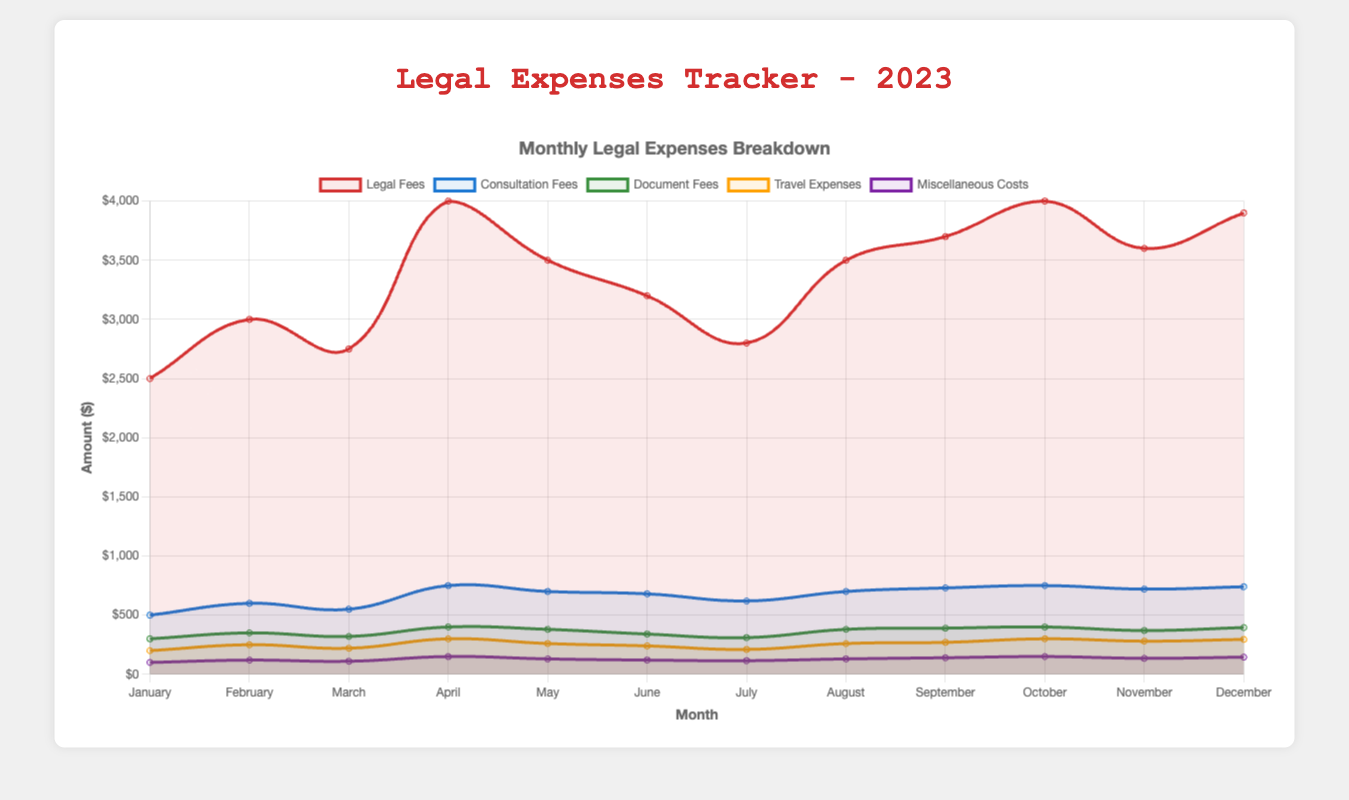What's the highest legal fee recorded in 2023? The highest legal fee can be found by looking at the peak value in the "Legal Fees" line. According to the chart, both April and October have the highest value of $4000.
Answer: $4000 Which month had the lowest consultation fees? To find the month with the lowest consultation fees, trace the "Consultation Fees" line to the lowest point on the chart. January has the lowest consultation fees at $500.
Answer: January What is the total amount spent on miscellaneous costs in the first quarter of 2023? The first quarter includes January, February, and March. Summing up the miscellaneous costs for these months: $100 (January) + $120 (February) + $110 (March) = $330.
Answer: $330 How do the travel expenses in June compare to those in November? June's travel expenses are $240, while November's travel expenses are $280. Comparing these values, November's travel expenses are higher.
Answer: November has higher travel expenses What is the overall trend in legal fees from January to December 2023? To identify the trend, observe the "Legal Fees" line from January to December. Initially, there's an upward trend until April, followed by fluctuations, and a peak in October before ending at a slightly lower value in December.
Answer: Fluctuating with peaks in April and October Which month had the highest total costs when combining all categories? To find the month with the highest total costs, sum all the categories (Legal Fees, Consultation Fees, Document Fees, Travel Expenses, Miscellaneous Costs) for each month and compare. April has $4000 (Legal Fees) + $750 (Consultation Fees) + $400 (Document Fees) + $300 (Travel Expenses) + $150 (Miscellaneous Costs) = $5600. This is the highest combined cost.
Answer: April What is the average document fee over the entire year? Sum of all monthly document fees divided by the number of months: ($300 + $350 + $320 + $400 + $380 + $340 + $310 + $380 + $390 + $400 + $370 + $395) = $4335. Divide by 12 (number of months) to get 4335/12 = $361.25.
Answer: $361.25 How did consultation fees change from January to December? By observing the "Consultation Fees" line, it starts at $500 in January and peaks at $750 in April and October, ending at $740 in December. Overall, there's an increasing trend.
Answer: Increasing trend What is the difference in document fees between the month with the highest and the month with the lowest fees? The highest document fee is $400 (April and October), and the lowest is $300 (January). The difference is $400 - $300 = $100.
Answer: $100 Which month saw an equal value for both consultation fees and document fees? By examining the chart, both consultation fees and document fees share the same value of $400 in October.
Answer: October 